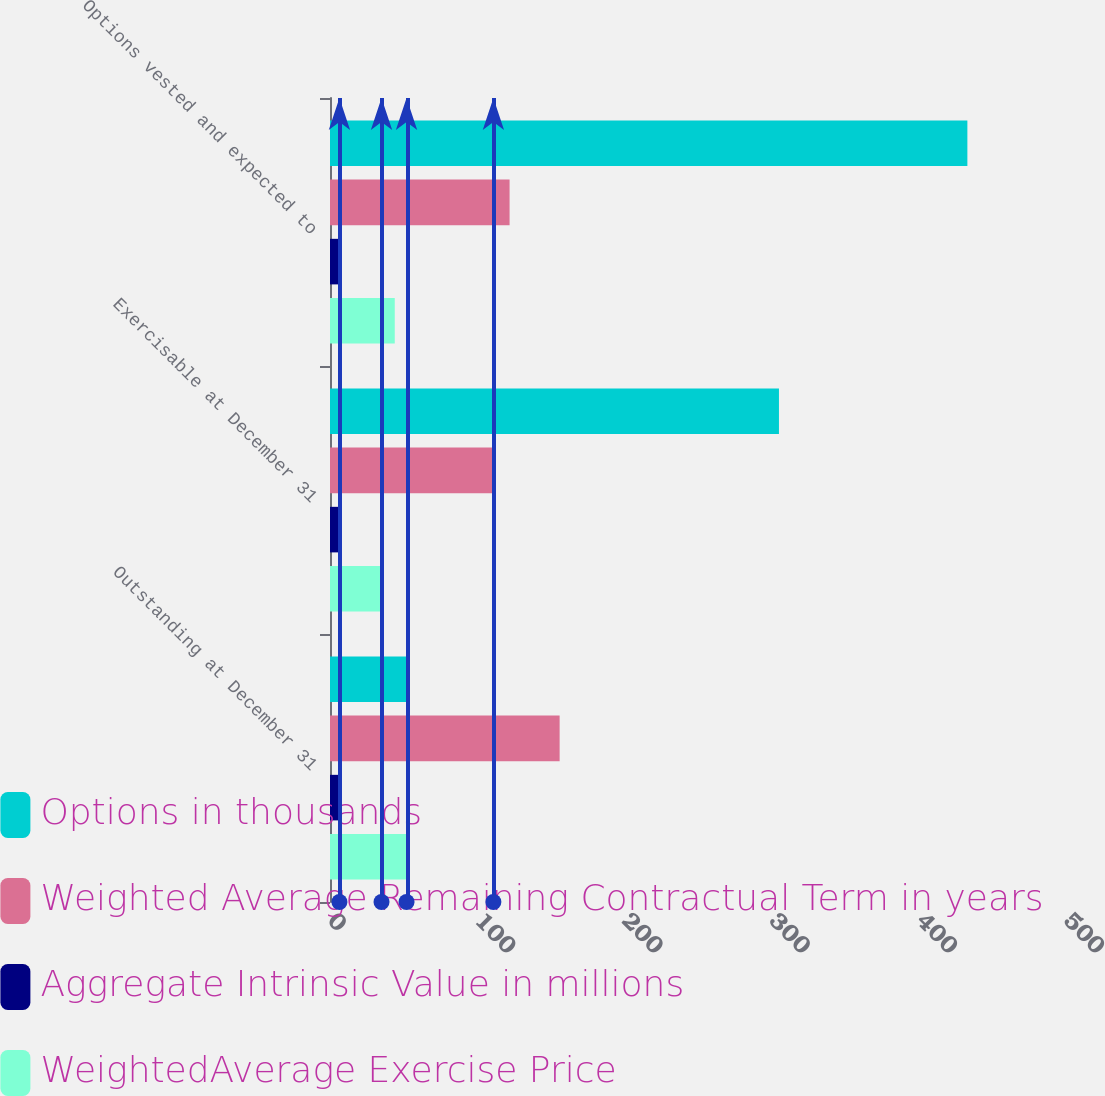Convert chart to OTSL. <chart><loc_0><loc_0><loc_500><loc_500><stacked_bar_chart><ecel><fcel>Outstanding at December 31<fcel>Exercisable at December 31<fcel>Options vested and expected to<nl><fcel>Options in thousands<fcel>52<fcel>305<fcel>433<nl><fcel>Weighted Average Remaining Contractual Term in years<fcel>156<fcel>111<fcel>122<nl><fcel>Aggregate Intrinsic Value in millions<fcel>7.4<fcel>6.4<fcel>6.7<nl><fcel>WeightedAverage Exercise Price<fcel>52<fcel>35<fcel>44<nl></chart> 